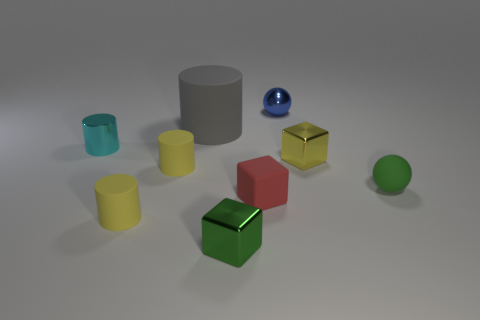Does the thing that is on the right side of the yellow metal block have the same size as the large cylinder?
Keep it short and to the point. No. There is a small shiny block in front of the tiny green rubber ball; is it the same color as the tiny rubber sphere?
Provide a short and direct response. Yes. How many matte cylinders are behind the tiny ball that is behind the rubber sphere?
Offer a terse response. 0. Is the size of the yellow block the same as the green matte thing?
Your response must be concise. Yes. What number of tiny spheres are the same material as the gray thing?
Provide a short and direct response. 1. The gray object that is the same shape as the tiny cyan metal thing is what size?
Give a very brief answer. Large. There is a tiny yellow thing that is in front of the green matte sphere; is it the same shape as the big gray matte object?
Your response must be concise. Yes. What is the shape of the metal thing that is on the left side of the small matte cylinder in front of the red thing?
Offer a very short reply. Cylinder. Is there any other thing that has the same shape as the big matte thing?
Keep it short and to the point. Yes. There is a small metal thing that is the same shape as the gray matte object; what color is it?
Ensure brevity in your answer.  Cyan. 